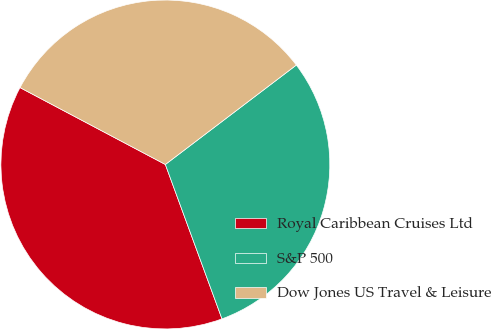Convert chart. <chart><loc_0><loc_0><loc_500><loc_500><pie_chart><fcel>Royal Caribbean Cruises Ltd<fcel>S&P 500<fcel>Dow Jones US Travel & Leisure<nl><fcel>38.34%<fcel>29.74%<fcel>31.92%<nl></chart> 